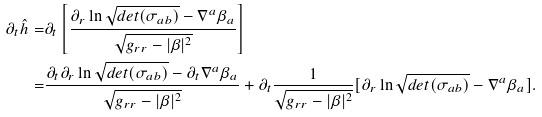Convert formula to latex. <formula><loc_0><loc_0><loc_500><loc_500>\partial _ { t } \hat { h } = & \partial _ { t } \left [ \frac { \partial _ { r } \ln \sqrt { d e t ( \sigma _ { a b } ) } - \nabla ^ { a } \beta _ { a } } { \sqrt { g _ { r r } - | \beta | ^ { 2 } } } \right ] \\ = & \frac { \partial _ { t } \partial _ { r } \ln \sqrt { d e t ( \sigma _ { a b } ) } - \partial _ { t } \nabla ^ { a } \beta _ { a } } { \sqrt { g _ { r r } - | \beta | ^ { 2 } } } + \partial _ { t } \frac { 1 } { \sqrt { g _ { r r } - | \beta | ^ { 2 } } } [ \partial _ { r } \ln \sqrt { d e t ( \sigma _ { a b } ) } - \nabla ^ { a } \beta _ { a } ] .</formula> 